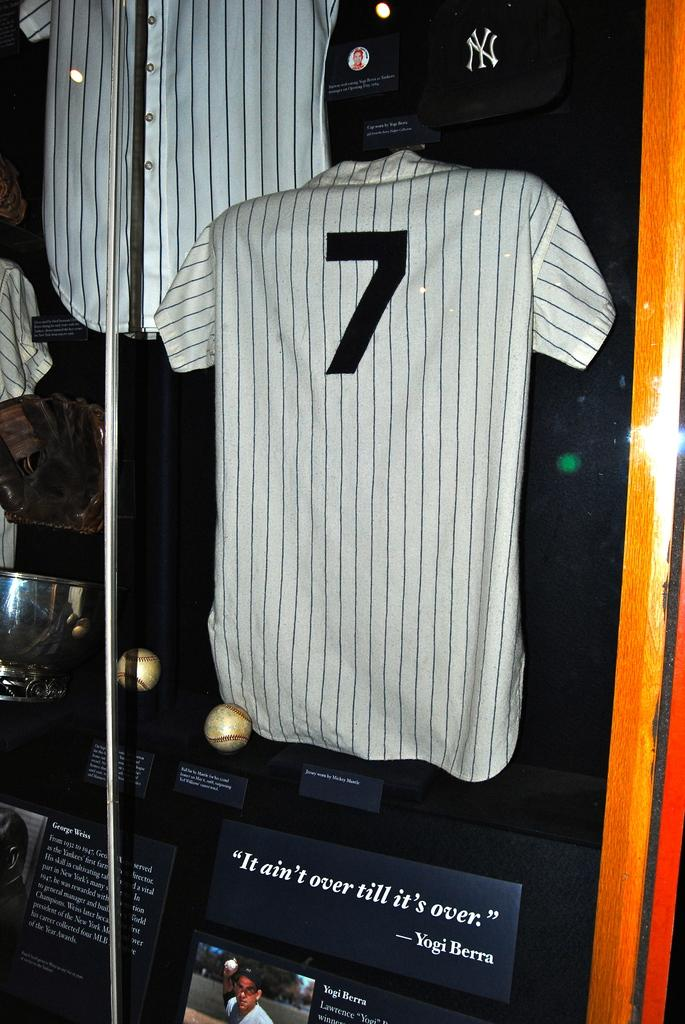<image>
Provide a brief description of the given image. A display of Yogi Berras uniform and a few collectibles including a famous quote. 